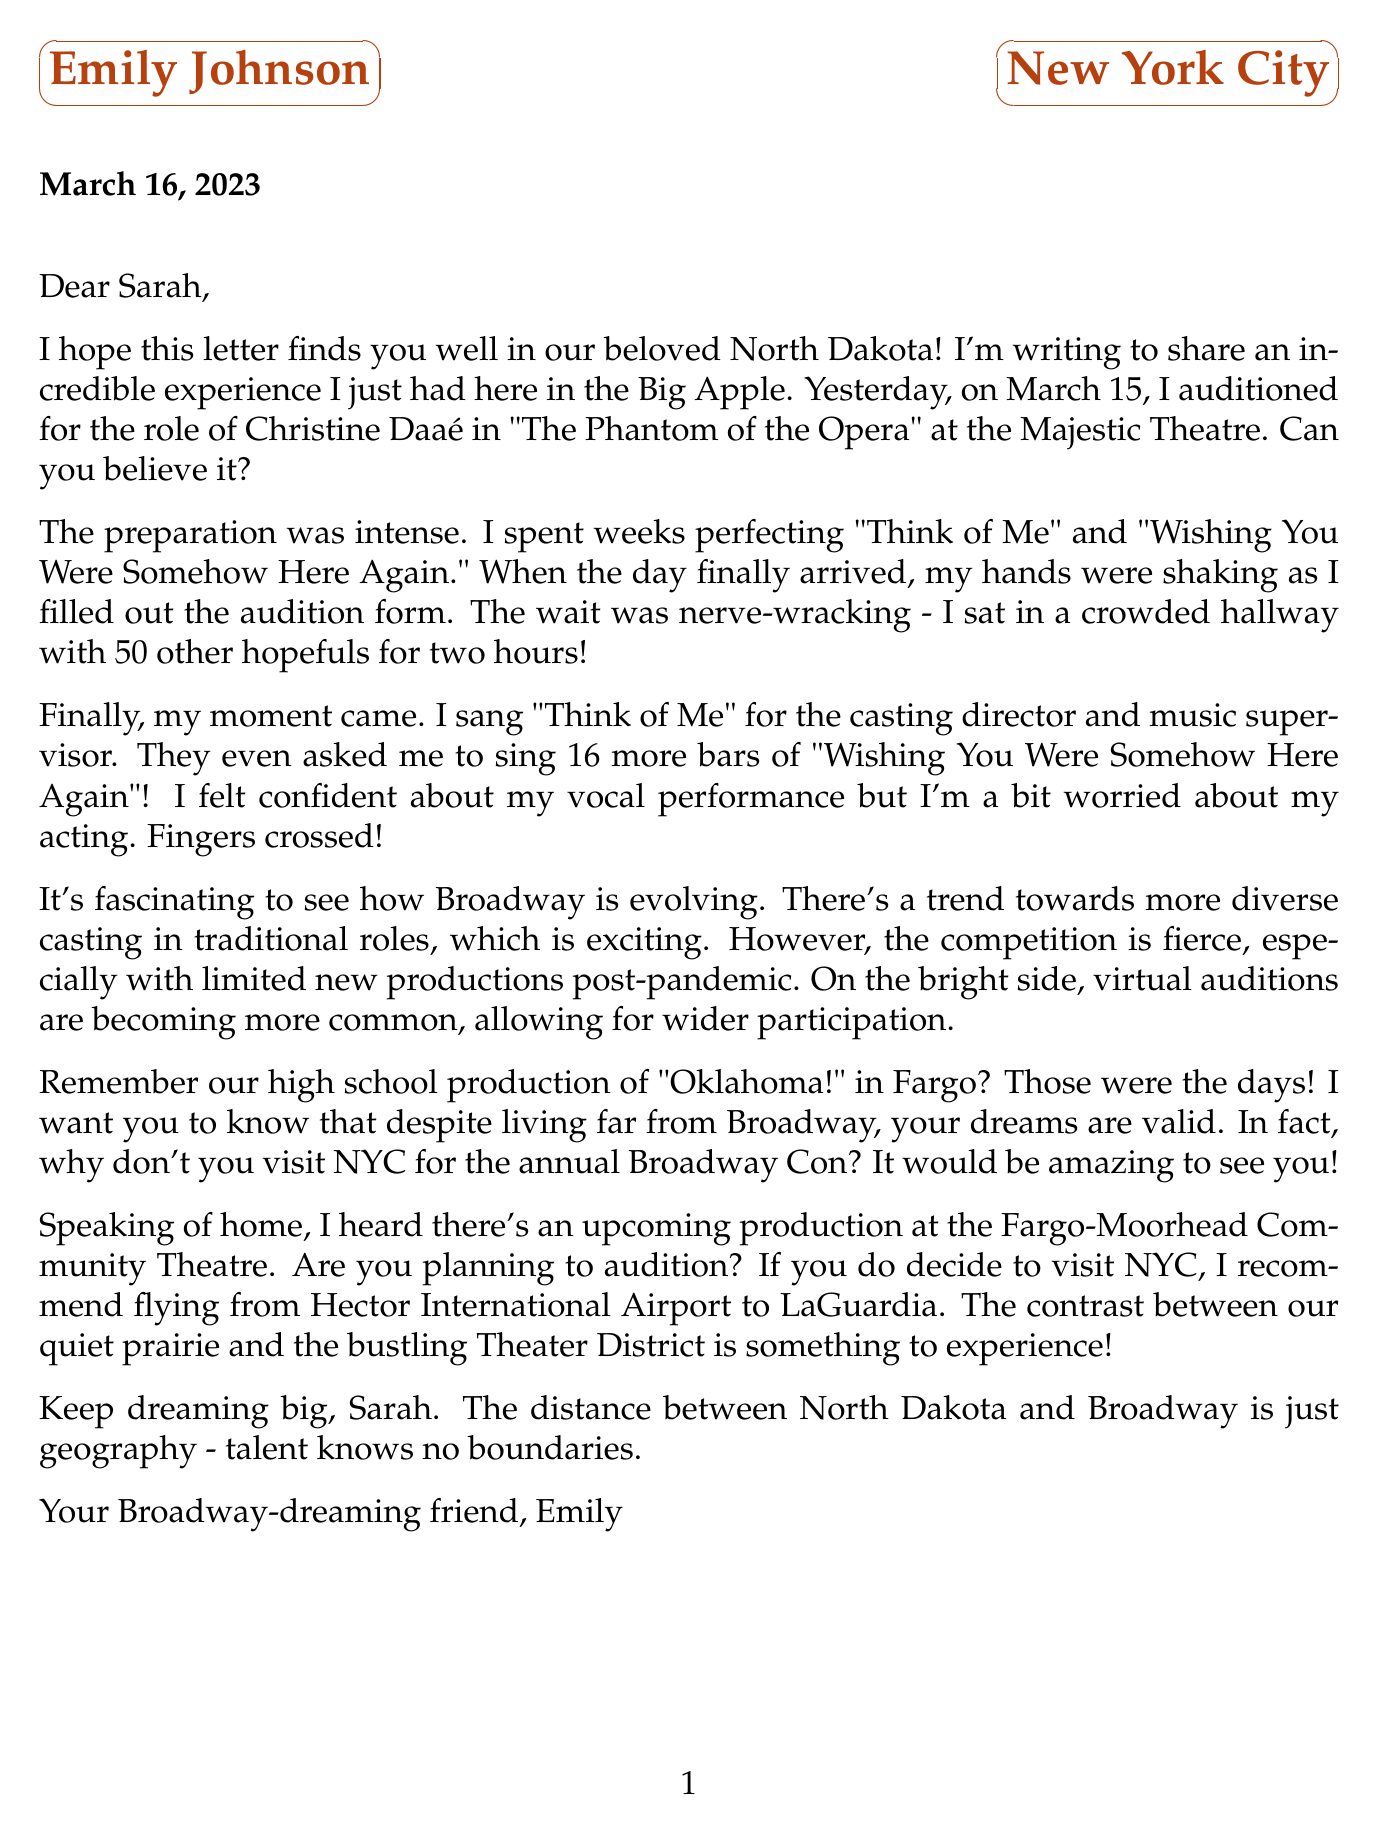What role did Emily audition for? Emily auditioned for the role of Christine Daaé in "The Phantom of the Opera."
Answer: Christine Daaé What date was the audition held? The audition for "The Phantom of the Opera" was held on March 15, 2023.
Answer: March 15, 2023 Where did Emily's audition take place? Emily's audition took place at the Majestic Theatre.
Answer: Majestic Theatre What song did Emily sing for the casting director? Emily sang "Think of Me" for the casting director and music supervisor.
Answer: Think of Me What does Emily recall about a past production? Emily remembers their high school production of "Oklahoma!" in Fargo.
Answer: Oklahoma! What recent trend in Broadway casting did Emily mention? Emily mentioned a trend towards more diverse casting in traditional roles.
Answer: More diverse casting What did Emily suggest Sarah to visit in NYC? Emily suggested that Sarah visit NYC for the annual Broadway Con.
Answer: Broadway Con What travel tip did Emily give for visiting NYC? Emily recommended flying from Hector International Airport to LaGuardia.
Answer: Hector International Airport to LaGuardia 